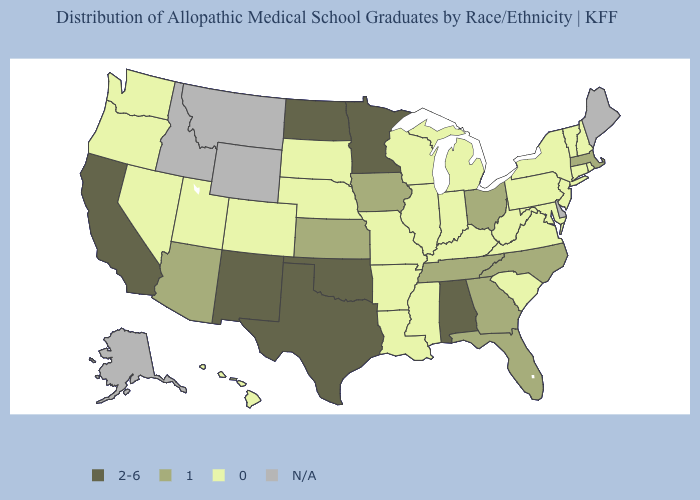Which states hav the highest value in the South?
Short answer required. Alabama, Oklahoma, Texas. What is the highest value in states that border Texas?
Be succinct. 2-6. What is the value of Maryland?
Be succinct. 0. Does Nebraska have the lowest value in the MidWest?
Keep it brief. Yes. Among the states that border Texas , does Arkansas have the lowest value?
Answer briefly. Yes. What is the highest value in the South ?
Write a very short answer. 2-6. What is the lowest value in the USA?
Give a very brief answer. 0. Does the map have missing data?
Keep it brief. Yes. Name the states that have a value in the range N/A?
Keep it brief. Alaska, Delaware, Idaho, Maine, Montana, Wyoming. Does Massachusetts have the lowest value in the Northeast?
Write a very short answer. No. Among the states that border Oklahoma , which have the highest value?
Give a very brief answer. New Mexico, Texas. Which states have the lowest value in the USA?
Quick response, please. Arkansas, Colorado, Connecticut, Hawaii, Illinois, Indiana, Kentucky, Louisiana, Maryland, Michigan, Mississippi, Missouri, Nebraska, Nevada, New Hampshire, New Jersey, New York, Oregon, Pennsylvania, Rhode Island, South Carolina, South Dakota, Utah, Vermont, Virginia, Washington, West Virginia, Wisconsin. What is the lowest value in states that border Kentucky?
Keep it brief. 0. 